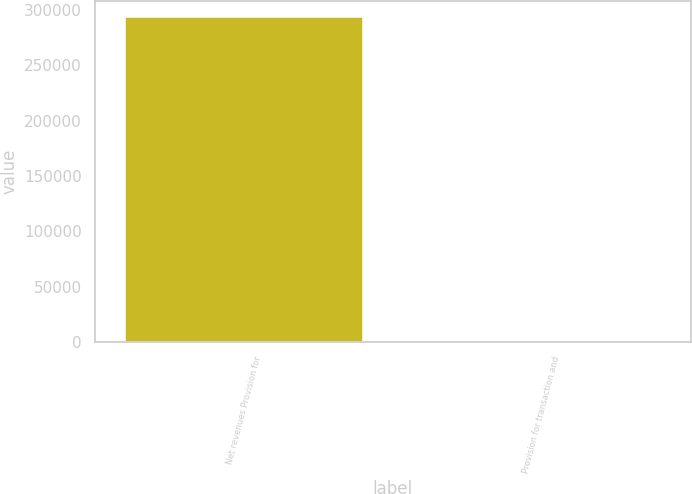Convert chart. <chart><loc_0><loc_0><loc_500><loc_500><bar_chart><fcel>Net revenues Provision for<fcel>Provision for transaction and<nl><fcel>293917<fcel>3.8<nl></chart> 